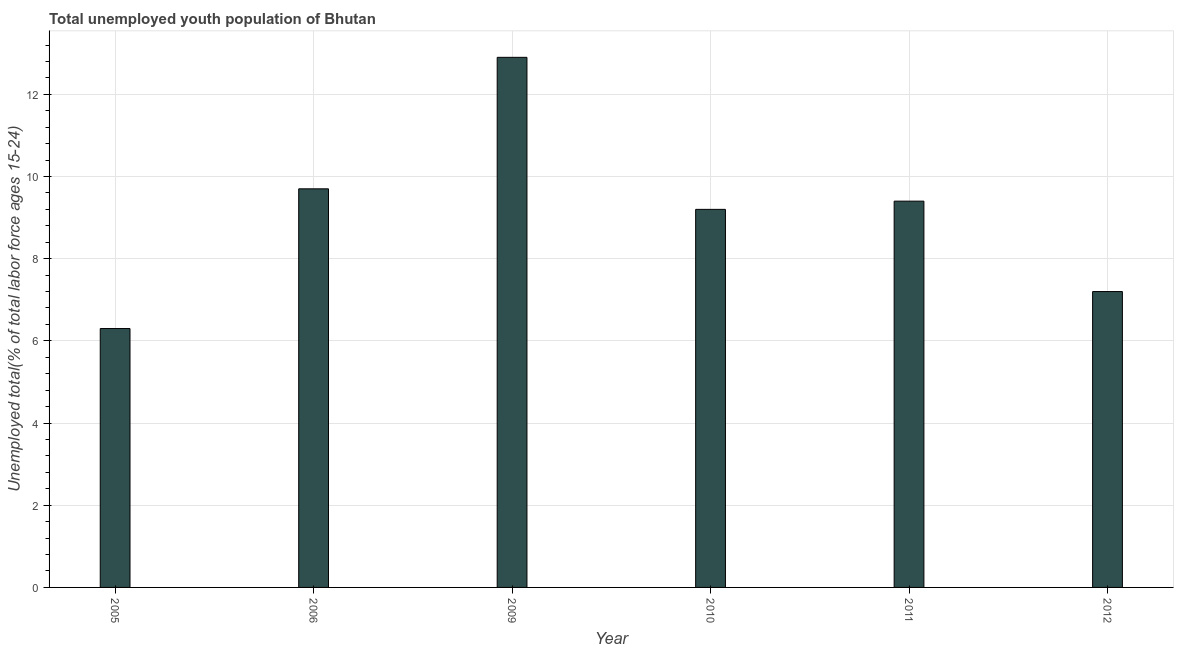Does the graph contain any zero values?
Make the answer very short. No. What is the title of the graph?
Your answer should be compact. Total unemployed youth population of Bhutan. What is the label or title of the Y-axis?
Your answer should be very brief. Unemployed total(% of total labor force ages 15-24). What is the unemployed youth in 2009?
Give a very brief answer. 12.9. Across all years, what is the maximum unemployed youth?
Keep it short and to the point. 12.9. Across all years, what is the minimum unemployed youth?
Provide a short and direct response. 6.3. In which year was the unemployed youth minimum?
Provide a succinct answer. 2005. What is the sum of the unemployed youth?
Provide a short and direct response. 54.7. What is the average unemployed youth per year?
Offer a very short reply. 9.12. What is the median unemployed youth?
Make the answer very short. 9.3. In how many years, is the unemployed youth greater than 4 %?
Provide a succinct answer. 6. What is the ratio of the unemployed youth in 2005 to that in 2010?
Offer a terse response. 0.69. What is the difference between the highest and the second highest unemployed youth?
Your response must be concise. 3.2. What is the difference between the highest and the lowest unemployed youth?
Keep it short and to the point. 6.6. How many years are there in the graph?
Provide a succinct answer. 6. What is the Unemployed total(% of total labor force ages 15-24) of 2005?
Ensure brevity in your answer.  6.3. What is the Unemployed total(% of total labor force ages 15-24) in 2006?
Offer a terse response. 9.7. What is the Unemployed total(% of total labor force ages 15-24) of 2009?
Ensure brevity in your answer.  12.9. What is the Unemployed total(% of total labor force ages 15-24) of 2010?
Provide a succinct answer. 9.2. What is the Unemployed total(% of total labor force ages 15-24) in 2011?
Ensure brevity in your answer.  9.4. What is the Unemployed total(% of total labor force ages 15-24) of 2012?
Provide a short and direct response. 7.2. What is the difference between the Unemployed total(% of total labor force ages 15-24) in 2005 and 2009?
Give a very brief answer. -6.6. What is the difference between the Unemployed total(% of total labor force ages 15-24) in 2005 and 2011?
Give a very brief answer. -3.1. What is the difference between the Unemployed total(% of total labor force ages 15-24) in 2005 and 2012?
Your response must be concise. -0.9. What is the difference between the Unemployed total(% of total labor force ages 15-24) in 2006 and 2009?
Give a very brief answer. -3.2. What is the difference between the Unemployed total(% of total labor force ages 15-24) in 2006 and 2010?
Ensure brevity in your answer.  0.5. What is the difference between the Unemployed total(% of total labor force ages 15-24) in 2006 and 2011?
Provide a short and direct response. 0.3. What is the difference between the Unemployed total(% of total labor force ages 15-24) in 2006 and 2012?
Provide a succinct answer. 2.5. What is the difference between the Unemployed total(% of total labor force ages 15-24) in 2009 and 2012?
Provide a short and direct response. 5.7. What is the difference between the Unemployed total(% of total labor force ages 15-24) in 2010 and 2011?
Keep it short and to the point. -0.2. What is the difference between the Unemployed total(% of total labor force ages 15-24) in 2010 and 2012?
Offer a very short reply. 2. What is the ratio of the Unemployed total(% of total labor force ages 15-24) in 2005 to that in 2006?
Provide a succinct answer. 0.65. What is the ratio of the Unemployed total(% of total labor force ages 15-24) in 2005 to that in 2009?
Offer a terse response. 0.49. What is the ratio of the Unemployed total(% of total labor force ages 15-24) in 2005 to that in 2010?
Offer a terse response. 0.69. What is the ratio of the Unemployed total(% of total labor force ages 15-24) in 2005 to that in 2011?
Provide a succinct answer. 0.67. What is the ratio of the Unemployed total(% of total labor force ages 15-24) in 2006 to that in 2009?
Your response must be concise. 0.75. What is the ratio of the Unemployed total(% of total labor force ages 15-24) in 2006 to that in 2010?
Make the answer very short. 1.05. What is the ratio of the Unemployed total(% of total labor force ages 15-24) in 2006 to that in 2011?
Ensure brevity in your answer.  1.03. What is the ratio of the Unemployed total(% of total labor force ages 15-24) in 2006 to that in 2012?
Make the answer very short. 1.35. What is the ratio of the Unemployed total(% of total labor force ages 15-24) in 2009 to that in 2010?
Provide a short and direct response. 1.4. What is the ratio of the Unemployed total(% of total labor force ages 15-24) in 2009 to that in 2011?
Your answer should be very brief. 1.37. What is the ratio of the Unemployed total(% of total labor force ages 15-24) in 2009 to that in 2012?
Provide a succinct answer. 1.79. What is the ratio of the Unemployed total(% of total labor force ages 15-24) in 2010 to that in 2011?
Your response must be concise. 0.98. What is the ratio of the Unemployed total(% of total labor force ages 15-24) in 2010 to that in 2012?
Your response must be concise. 1.28. What is the ratio of the Unemployed total(% of total labor force ages 15-24) in 2011 to that in 2012?
Keep it short and to the point. 1.31. 